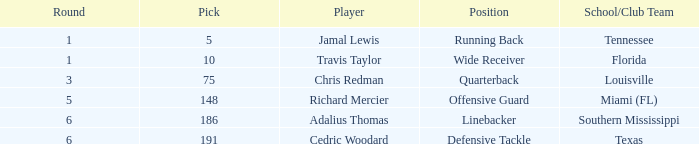Where's the first round that southern mississippi shows up during the draft? 6.0. 